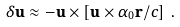<formula> <loc_0><loc_0><loc_500><loc_500>\delta \mathbf u \approx - \mathbf u \times \left [ \mathbf u \times \alpha _ { 0 } \mathbf r / c \right ] \, .</formula> 